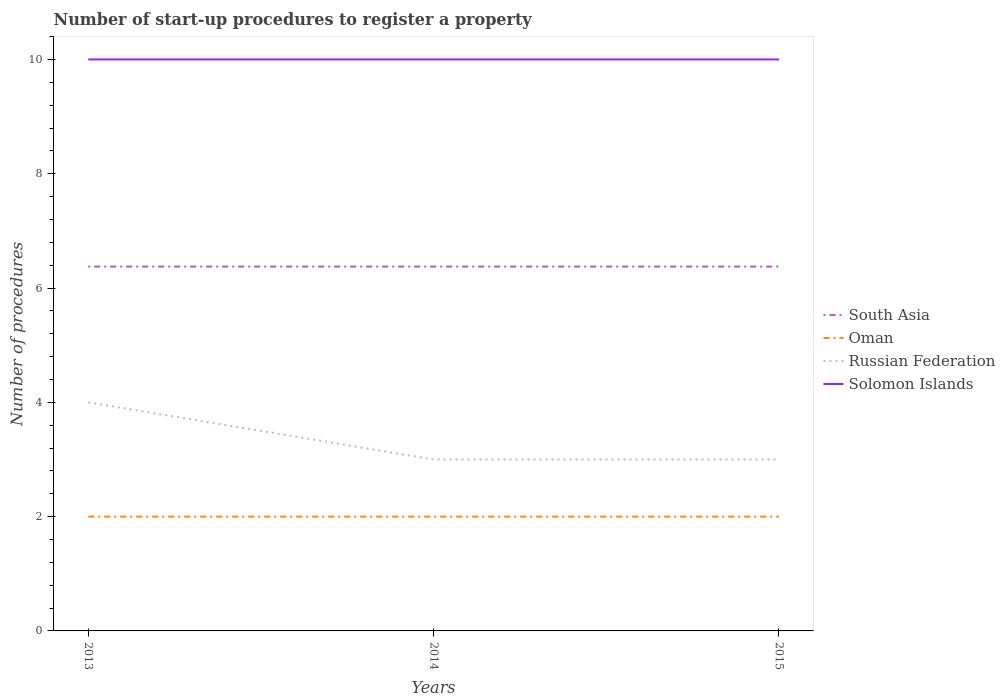How many different coloured lines are there?
Give a very brief answer. 4. Is the number of lines equal to the number of legend labels?
Make the answer very short. Yes. Across all years, what is the maximum number of procedures required to register a property in South Asia?
Provide a short and direct response. 6.38. In which year was the number of procedures required to register a property in Russian Federation maximum?
Make the answer very short. 2014. What is the total number of procedures required to register a property in Oman in the graph?
Keep it short and to the point. 0. What is the difference between the highest and the lowest number of procedures required to register a property in Solomon Islands?
Offer a terse response. 0. Is the number of procedures required to register a property in Russian Federation strictly greater than the number of procedures required to register a property in Oman over the years?
Provide a short and direct response. No. How many lines are there?
Provide a succinct answer. 4. Are the values on the major ticks of Y-axis written in scientific E-notation?
Give a very brief answer. No. Does the graph contain grids?
Make the answer very short. No. Where does the legend appear in the graph?
Provide a succinct answer. Center right. How are the legend labels stacked?
Your answer should be compact. Vertical. What is the title of the graph?
Your answer should be compact. Number of start-up procedures to register a property. Does "Puerto Rico" appear as one of the legend labels in the graph?
Give a very brief answer. No. What is the label or title of the Y-axis?
Your response must be concise. Number of procedures. What is the Number of procedures of South Asia in 2013?
Keep it short and to the point. 6.38. What is the Number of procedures of Oman in 2013?
Provide a short and direct response. 2. What is the Number of procedures in Russian Federation in 2013?
Give a very brief answer. 4. What is the Number of procedures in Solomon Islands in 2013?
Offer a terse response. 10. What is the Number of procedures of South Asia in 2014?
Offer a very short reply. 6.38. What is the Number of procedures of South Asia in 2015?
Your answer should be very brief. 6.38. What is the Number of procedures in Oman in 2015?
Give a very brief answer. 2. What is the Number of procedures of Solomon Islands in 2015?
Your answer should be very brief. 10. Across all years, what is the maximum Number of procedures of South Asia?
Your answer should be compact. 6.38. Across all years, what is the minimum Number of procedures in South Asia?
Keep it short and to the point. 6.38. Across all years, what is the minimum Number of procedures in Oman?
Your response must be concise. 2. What is the total Number of procedures in South Asia in the graph?
Offer a terse response. 19.12. What is the total Number of procedures of Oman in the graph?
Your answer should be compact. 6. What is the total Number of procedures of Solomon Islands in the graph?
Ensure brevity in your answer.  30. What is the difference between the Number of procedures in Russian Federation in 2013 and that in 2014?
Make the answer very short. 1. What is the difference between the Number of procedures in Russian Federation in 2013 and that in 2015?
Your answer should be very brief. 1. What is the difference between the Number of procedures of Solomon Islands in 2013 and that in 2015?
Give a very brief answer. 0. What is the difference between the Number of procedures of South Asia in 2013 and the Number of procedures of Oman in 2014?
Keep it short and to the point. 4.38. What is the difference between the Number of procedures in South Asia in 2013 and the Number of procedures in Russian Federation in 2014?
Keep it short and to the point. 3.38. What is the difference between the Number of procedures in South Asia in 2013 and the Number of procedures in Solomon Islands in 2014?
Provide a short and direct response. -3.62. What is the difference between the Number of procedures of Russian Federation in 2013 and the Number of procedures of Solomon Islands in 2014?
Your answer should be very brief. -6. What is the difference between the Number of procedures in South Asia in 2013 and the Number of procedures in Oman in 2015?
Keep it short and to the point. 4.38. What is the difference between the Number of procedures of South Asia in 2013 and the Number of procedures of Russian Federation in 2015?
Give a very brief answer. 3.38. What is the difference between the Number of procedures in South Asia in 2013 and the Number of procedures in Solomon Islands in 2015?
Your response must be concise. -3.62. What is the difference between the Number of procedures of Oman in 2013 and the Number of procedures of Solomon Islands in 2015?
Your response must be concise. -8. What is the difference between the Number of procedures in South Asia in 2014 and the Number of procedures in Oman in 2015?
Ensure brevity in your answer.  4.38. What is the difference between the Number of procedures in South Asia in 2014 and the Number of procedures in Russian Federation in 2015?
Make the answer very short. 3.38. What is the difference between the Number of procedures in South Asia in 2014 and the Number of procedures in Solomon Islands in 2015?
Provide a short and direct response. -3.62. What is the difference between the Number of procedures of Oman in 2014 and the Number of procedures of Russian Federation in 2015?
Provide a short and direct response. -1. What is the difference between the Number of procedures of Oman in 2014 and the Number of procedures of Solomon Islands in 2015?
Provide a short and direct response. -8. What is the average Number of procedures in South Asia per year?
Ensure brevity in your answer.  6.38. In the year 2013, what is the difference between the Number of procedures of South Asia and Number of procedures of Oman?
Offer a terse response. 4.38. In the year 2013, what is the difference between the Number of procedures in South Asia and Number of procedures in Russian Federation?
Offer a terse response. 2.38. In the year 2013, what is the difference between the Number of procedures in South Asia and Number of procedures in Solomon Islands?
Make the answer very short. -3.62. In the year 2013, what is the difference between the Number of procedures of Oman and Number of procedures of Russian Federation?
Your answer should be very brief. -2. In the year 2013, what is the difference between the Number of procedures of Russian Federation and Number of procedures of Solomon Islands?
Ensure brevity in your answer.  -6. In the year 2014, what is the difference between the Number of procedures in South Asia and Number of procedures in Oman?
Your response must be concise. 4.38. In the year 2014, what is the difference between the Number of procedures of South Asia and Number of procedures of Russian Federation?
Your response must be concise. 3.38. In the year 2014, what is the difference between the Number of procedures in South Asia and Number of procedures in Solomon Islands?
Make the answer very short. -3.62. In the year 2015, what is the difference between the Number of procedures in South Asia and Number of procedures in Oman?
Offer a very short reply. 4.38. In the year 2015, what is the difference between the Number of procedures in South Asia and Number of procedures in Russian Federation?
Provide a succinct answer. 3.38. In the year 2015, what is the difference between the Number of procedures of South Asia and Number of procedures of Solomon Islands?
Provide a short and direct response. -3.62. In the year 2015, what is the difference between the Number of procedures of Oman and Number of procedures of Russian Federation?
Make the answer very short. -1. In the year 2015, what is the difference between the Number of procedures of Russian Federation and Number of procedures of Solomon Islands?
Provide a succinct answer. -7. What is the ratio of the Number of procedures in Solomon Islands in 2013 to that in 2014?
Keep it short and to the point. 1. What is the ratio of the Number of procedures of South Asia in 2013 to that in 2015?
Provide a succinct answer. 1. What is the ratio of the Number of procedures in Solomon Islands in 2013 to that in 2015?
Offer a very short reply. 1. What is the ratio of the Number of procedures in South Asia in 2014 to that in 2015?
Keep it short and to the point. 1. What is the ratio of the Number of procedures in Russian Federation in 2014 to that in 2015?
Provide a succinct answer. 1. What is the difference between the highest and the second highest Number of procedures in South Asia?
Give a very brief answer. 0. What is the difference between the highest and the second highest Number of procedures of Oman?
Ensure brevity in your answer.  0. What is the difference between the highest and the lowest Number of procedures in South Asia?
Ensure brevity in your answer.  0. 